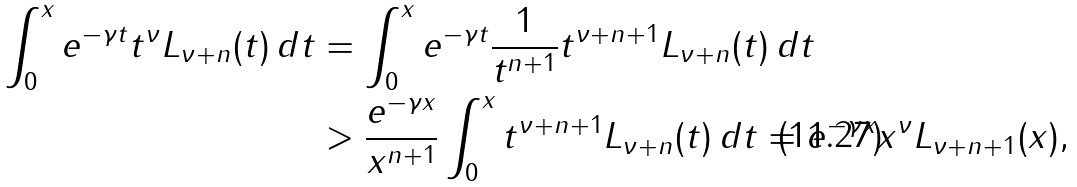<formula> <loc_0><loc_0><loc_500><loc_500>\int _ { 0 } ^ { x } e ^ { - \gamma t } t ^ { \nu } L _ { \nu + n } ( t ) \, d t & = \int _ { 0 } ^ { x } e ^ { - \gamma t } \frac { 1 } { t ^ { n + 1 } } t ^ { \nu + n + 1 } L _ { \nu + n } ( t ) \, d t \\ & > \frac { e ^ { - \gamma x } } { x ^ { n + 1 } } \int _ { 0 } ^ { x } t ^ { \nu + n + 1 } L _ { \nu + n } ( t ) \, d t = e ^ { - \gamma x } x ^ { \nu } L _ { \nu + n + 1 } ( x ) ,</formula> 